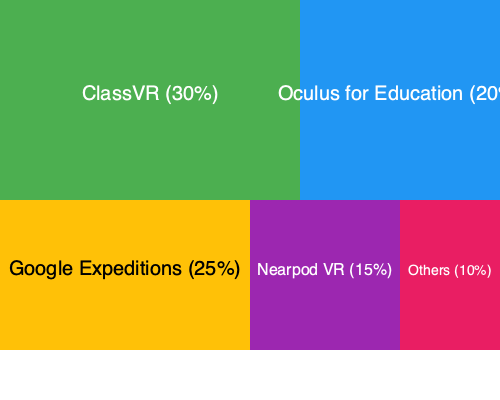Based on the treemap diagram showing the market share of various educational VR platforms, which platform has the largest market share, and what percentage does it hold? To determine the platform with the largest market share and its percentage, we need to analyze the treemap diagram:

1. Identify all platforms represented:
   - ClassVR
   - Oculus for Education
   - Google Expeditions
   - Nearpod VR
   - Others

2. Compare the sizes of the rectangles:
   The largest rectangle represents the platform with the highest market share.

3. Examine the percentages:
   - ClassVR: 30%
   - Oculus for Education: 20%
   - Google Expeditions: 25%
   - Nearpod VR: 15%
   - Others: 10%

4. Identify the largest percentage:
   ClassVR has the largest percentage at 30%.

Therefore, ClassVR has the largest market share among the educational VR platforms represented in the diagram, holding 30% of the market.
Answer: ClassVR, 30% 